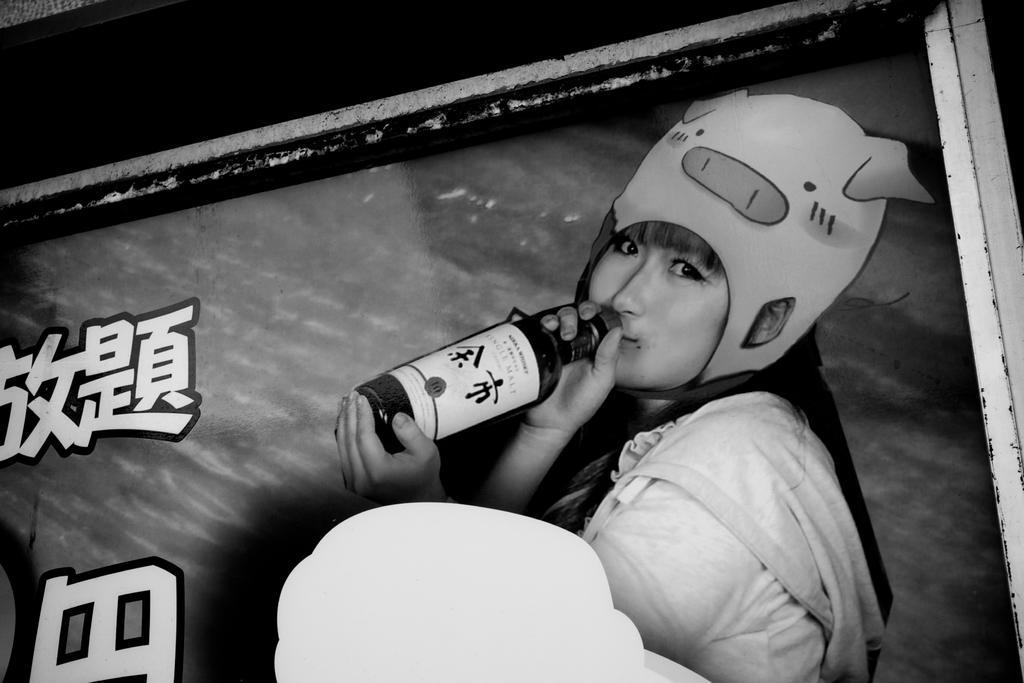Please provide a concise description of this image. In this image, There is a person wearing clothes and cap on her head. This person holding a bottle. 